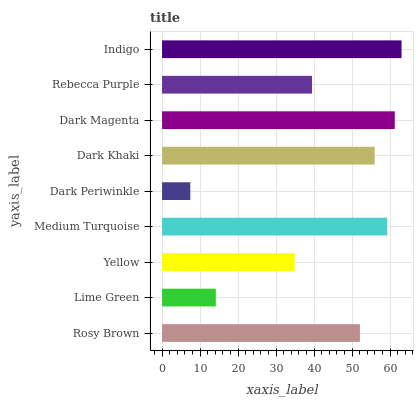Is Dark Periwinkle the minimum?
Answer yes or no. Yes. Is Indigo the maximum?
Answer yes or no. Yes. Is Lime Green the minimum?
Answer yes or no. No. Is Lime Green the maximum?
Answer yes or no. No. Is Rosy Brown greater than Lime Green?
Answer yes or no. Yes. Is Lime Green less than Rosy Brown?
Answer yes or no. Yes. Is Lime Green greater than Rosy Brown?
Answer yes or no. No. Is Rosy Brown less than Lime Green?
Answer yes or no. No. Is Rosy Brown the high median?
Answer yes or no. Yes. Is Rosy Brown the low median?
Answer yes or no. Yes. Is Dark Magenta the high median?
Answer yes or no. No. Is Rebecca Purple the low median?
Answer yes or no. No. 